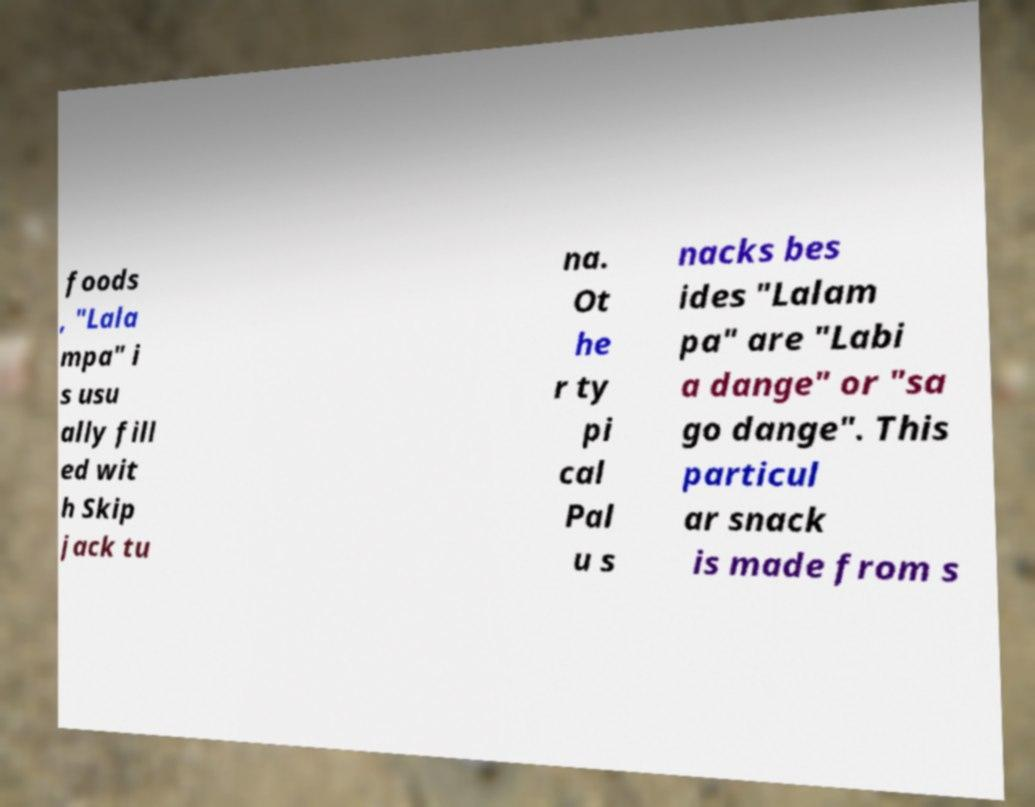There's text embedded in this image that I need extracted. Can you transcribe it verbatim? foods , "Lala mpa" i s usu ally fill ed wit h Skip jack tu na. Ot he r ty pi cal Pal u s nacks bes ides "Lalam pa" are "Labi a dange" or "sa go dange". This particul ar snack is made from s 